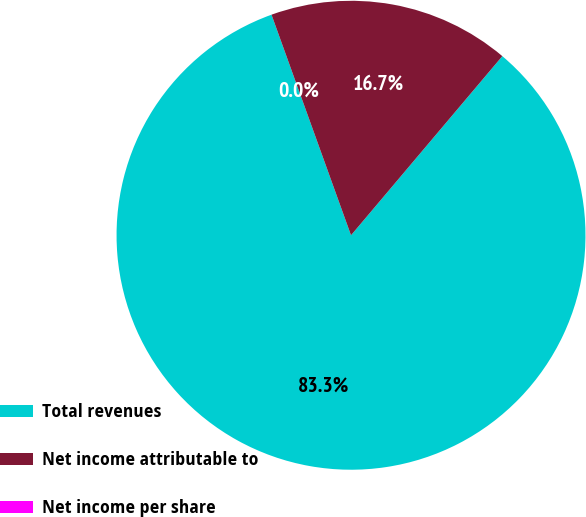Convert chart to OTSL. <chart><loc_0><loc_0><loc_500><loc_500><pie_chart><fcel>Total revenues<fcel>Net income attributable to<fcel>Net income per share<nl><fcel>83.33%<fcel>16.67%<fcel>0.0%<nl></chart> 